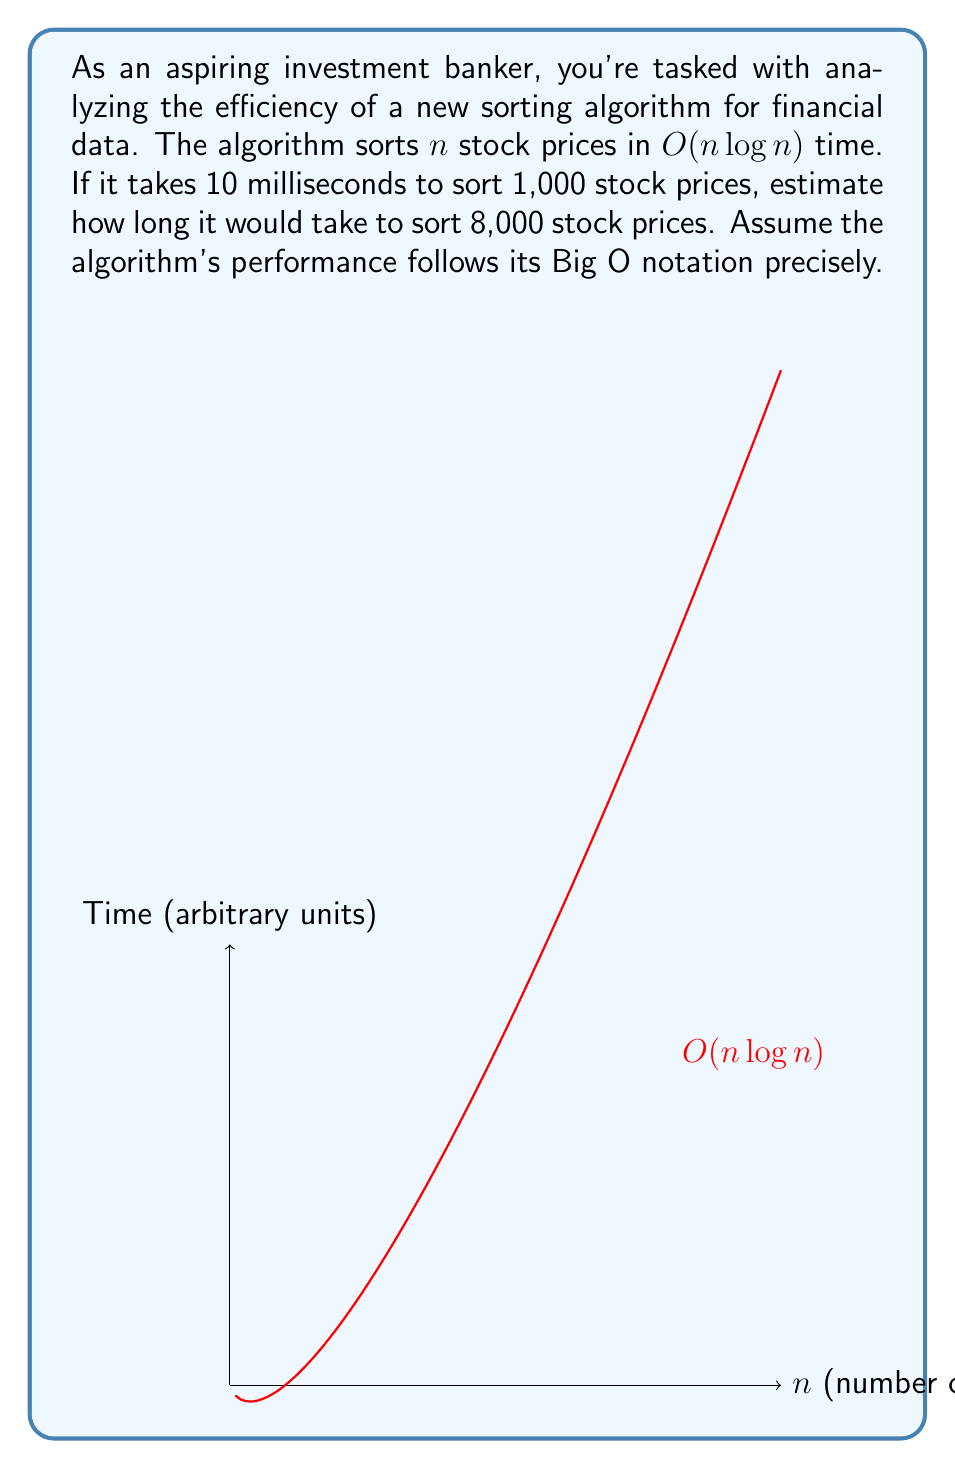Give your solution to this math problem. Let's approach this step-by-step:

1) The algorithm's time complexity is $O(n \log n)$. This means the time $T(n)$ is proportional to $n \log n$:

   $T(n) = k \cdot n \log n$, where $k$ is a constant.

2) We're given that for $n_1 = 1000$, $T(n_1) = 10$ ms. Let's use this to find $k$:

   $10 = k \cdot 1000 \log 1000$
   $10 = k \cdot 1000 \cdot \log_2 1000$ (assuming log base 2)
   $10 = k \cdot 1000 \cdot 9.97$
   $k = \frac{10}{9970} \approx 0.001003$

3) Now, we want to find $T(n_2)$ where $n_2 = 8000$:

   $T(n_2) = k \cdot 8000 \log_2 8000$
   $T(n_2) = 0.001003 \cdot 8000 \cdot 12.97$
   $T(n_2) = 104.15$ ms

4) To verify, let's check the ratio:

   $\frac{T(n_2)}{T(n_1)} = \frac{104.15}{10} = 10.415$

   $\frac{n_2 \log n_2}{n_1 \log n_1} = \frac{8000 \cdot 12.97}{1000 \cdot 9.97} = 10.415$

The ratios match, confirming our calculation.
Answer: 104.15 milliseconds 